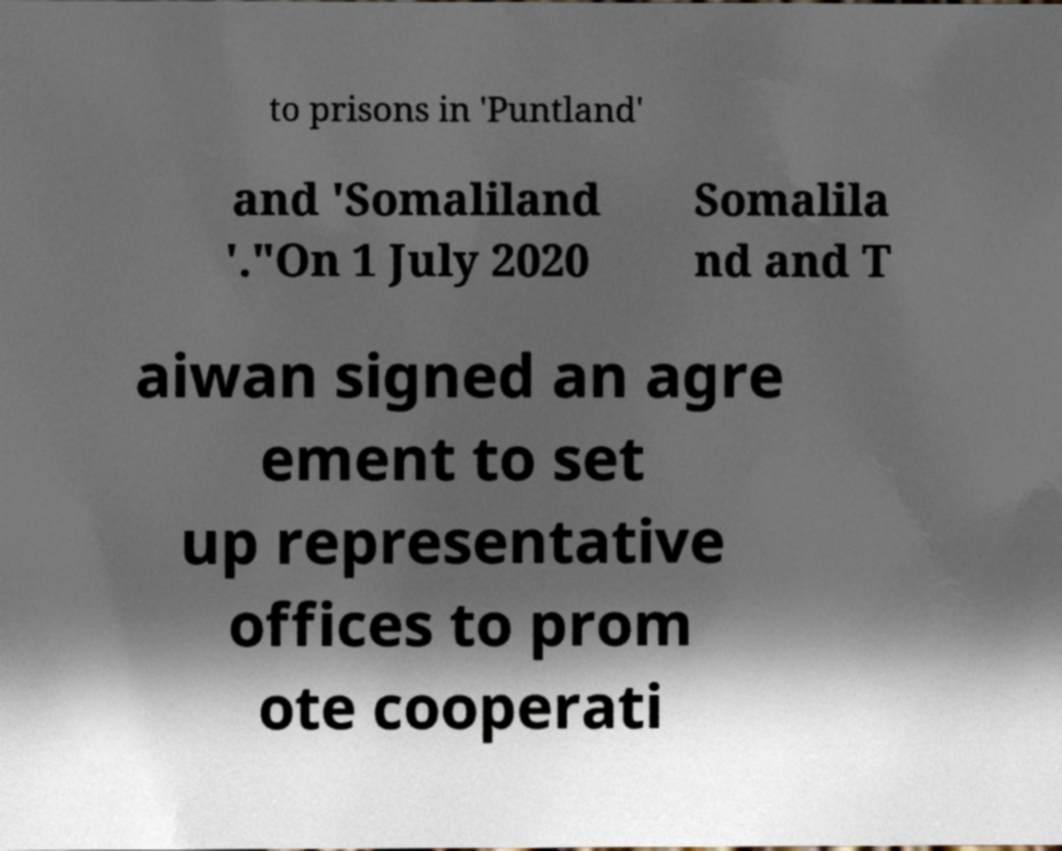For documentation purposes, I need the text within this image transcribed. Could you provide that? to prisons in 'Puntland' and 'Somaliland '."On 1 July 2020 Somalila nd and T aiwan signed an agre ement to set up representative offices to prom ote cooperati 